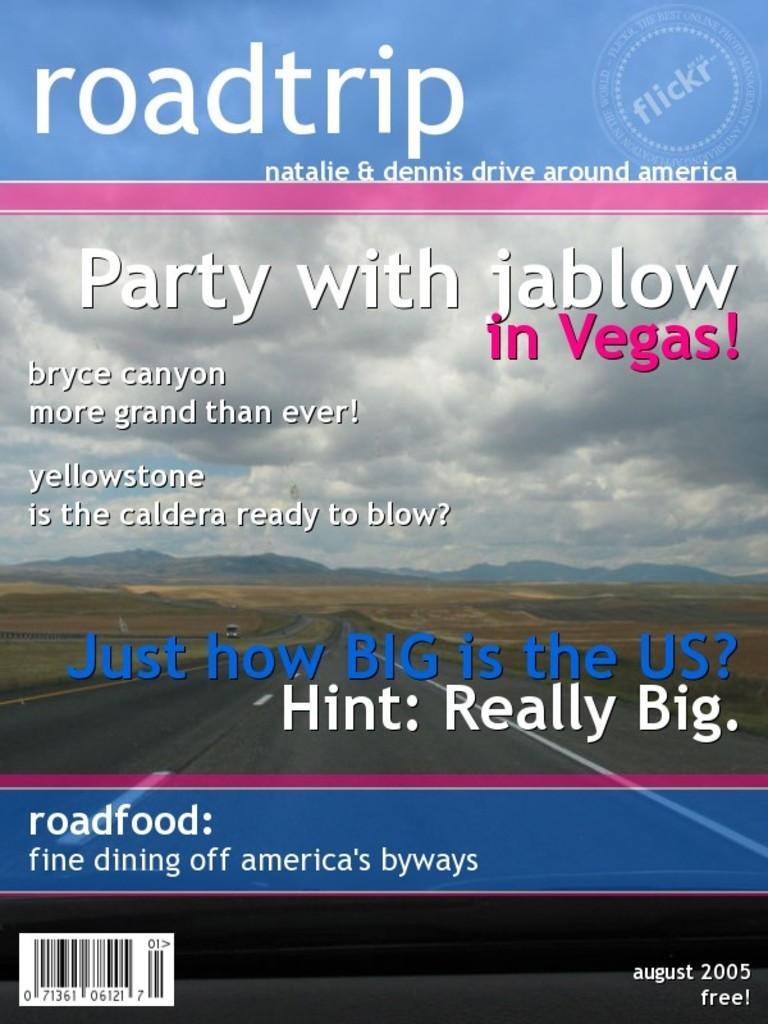<image>
Render a clear and concise summary of the photo. Cover showing a roadtrip and titled "Party with jablow in Vegas". 